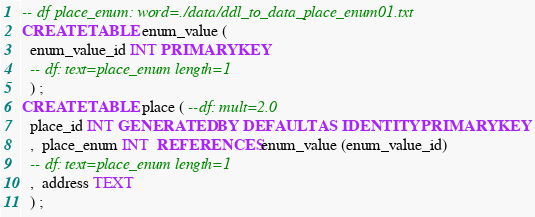Convert code to text. <code><loc_0><loc_0><loc_500><loc_500><_SQL_>-- df place_enum: word=./data/ddl_to_data_place_enum01.txt
CREATE TABLE enum_value (
  enum_value_id INT PRIMARY KEY
  -- df: text=place_enum length=1 
  ) ;
CREATE TABLE place ( --df: mult=2.0
  place_id INT GENERATED BY DEFAULT AS IDENTITY PRIMARY KEY
  ,  place_enum INT  REFERENCES enum_value (enum_value_id)
  -- df: text=place_enum length=1 
  ,  address TEXT 
  ) ;


</code> 